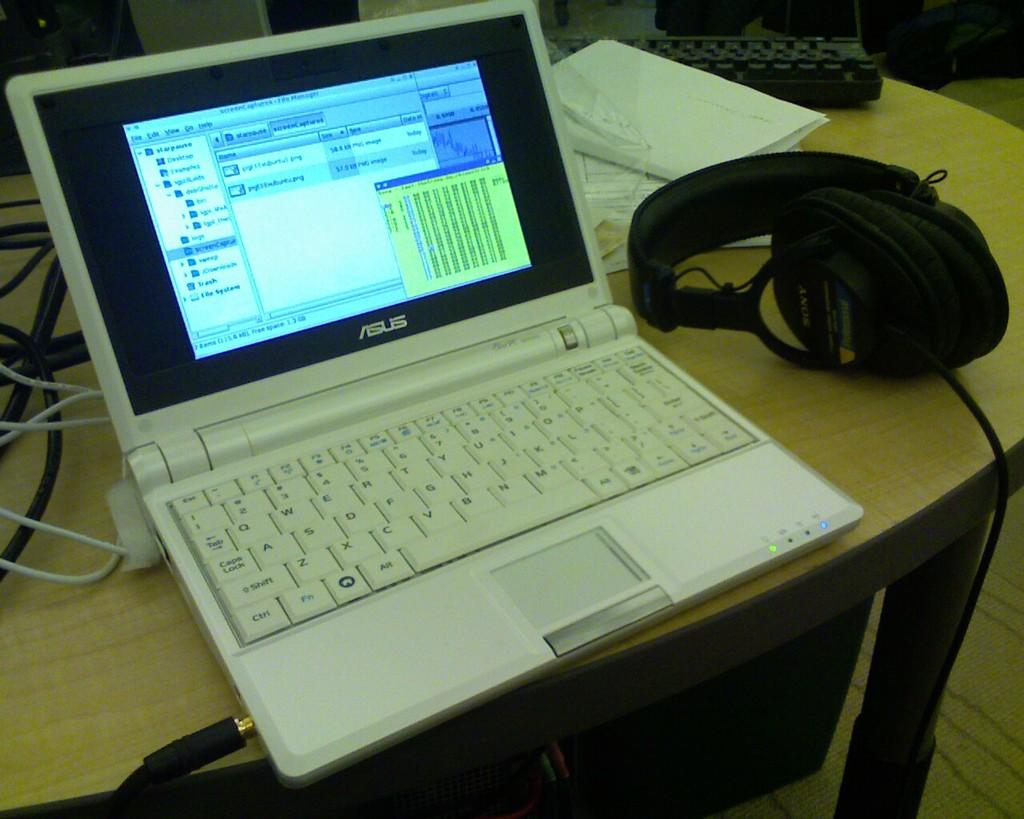Provide a one-sentence caption for the provided image. A white Asus laptop sits on a desk next to headphones. 